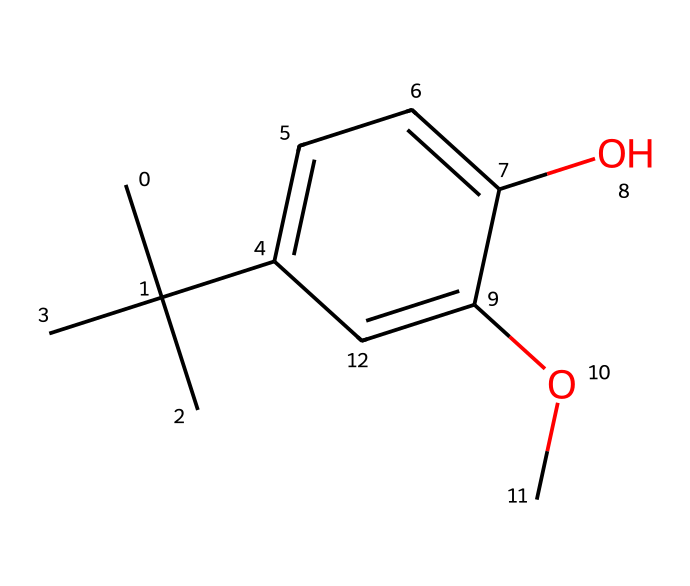What is the primary function of butylated hydroxyanisole (BHA)? BHA serves as an antioxidant preservative, preventing the oxidation of fats and oils in food products.
Answer: antioxidant preservative How many carbon atoms are present in the BHA structure? By analyzing the SMILES representation, one can count each carbon (C) symbol, which indicates carbon atoms. There are 11 carbon atoms in total in the structure.
Answer: 11 What type of chemical compound is butylated hydroxyanisole (BHA)? BHA is classified as a phenolic compound because its structure features a phenol group (hydroxy group attached to an aromatic ring).
Answer: phenolic Does BHA contain any functional groups? If so, which ones? In the SMILES representation, the presence of -OH (hydroxyl) indicates this compound has a phenolic functional group. Additionally, the -O- from the methoxy group also indicates another functional group.
Answer: hydroxyl and methoxy What is the molecular formula for butylated hydroxyanisole (BHA)? By analyzing the structure based on the count of carbon, hydrogen, and oxygen, one derives the molecular formula, C11H14O2.
Answer: C11H14O2 What is the role of the methoxy group in BHA's structure? The methoxy group enhances BHA's antioxidant activity, contributing to its effectiveness in preserving food by preventing rancidity.
Answer: enhances antioxidant activity 